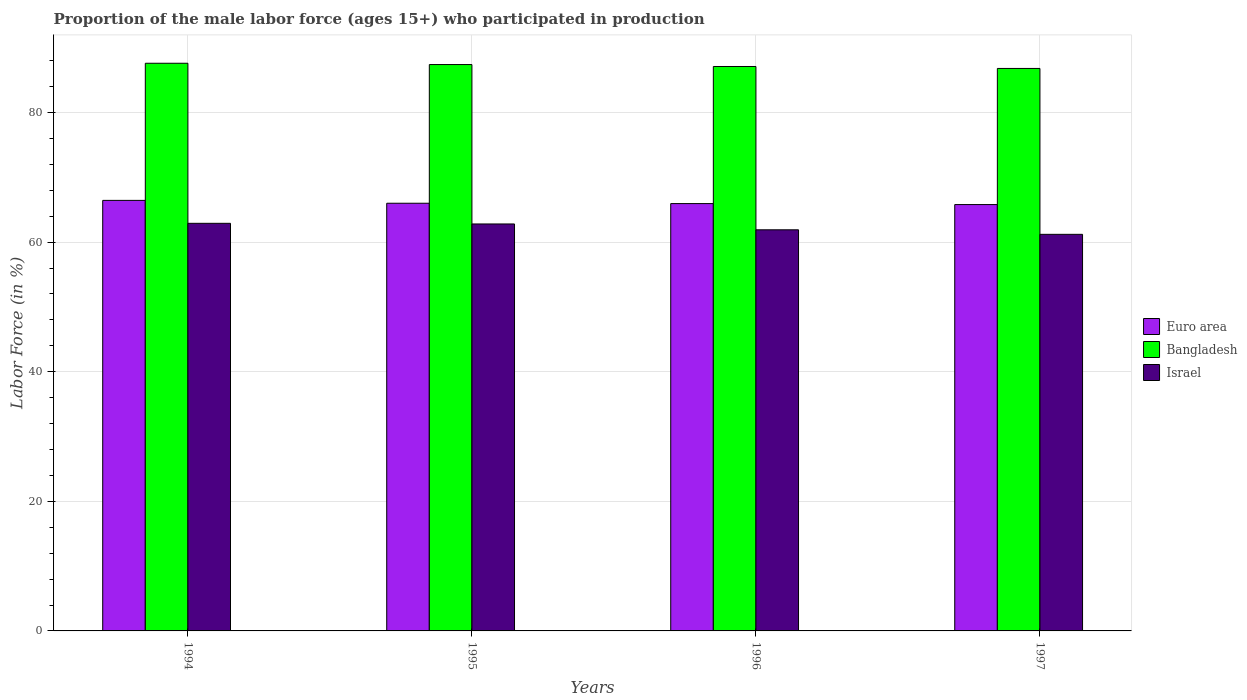How many different coloured bars are there?
Your answer should be compact. 3. Are the number of bars per tick equal to the number of legend labels?
Make the answer very short. Yes. How many bars are there on the 3rd tick from the left?
Your answer should be compact. 3. What is the label of the 3rd group of bars from the left?
Your answer should be very brief. 1996. What is the proportion of the male labor force who participated in production in Israel in 1997?
Your answer should be very brief. 61.2. Across all years, what is the maximum proportion of the male labor force who participated in production in Euro area?
Provide a short and direct response. 66.44. Across all years, what is the minimum proportion of the male labor force who participated in production in Euro area?
Provide a short and direct response. 65.79. In which year was the proportion of the male labor force who participated in production in Bangladesh maximum?
Provide a short and direct response. 1994. In which year was the proportion of the male labor force who participated in production in Euro area minimum?
Your answer should be compact. 1997. What is the total proportion of the male labor force who participated in production in Bangladesh in the graph?
Your response must be concise. 348.9. What is the difference between the proportion of the male labor force who participated in production in Israel in 1996 and that in 1997?
Provide a succinct answer. 0.7. What is the difference between the proportion of the male labor force who participated in production in Israel in 1996 and the proportion of the male labor force who participated in production in Bangladesh in 1994?
Your response must be concise. -25.7. What is the average proportion of the male labor force who participated in production in Euro area per year?
Your answer should be compact. 66.04. In the year 1996, what is the difference between the proportion of the male labor force who participated in production in Israel and proportion of the male labor force who participated in production in Bangladesh?
Ensure brevity in your answer.  -25.2. In how many years, is the proportion of the male labor force who participated in production in Bangladesh greater than 8 %?
Provide a succinct answer. 4. What is the ratio of the proportion of the male labor force who participated in production in Euro area in 1996 to that in 1997?
Offer a terse response. 1. Is the difference between the proportion of the male labor force who participated in production in Israel in 1994 and 1996 greater than the difference between the proportion of the male labor force who participated in production in Bangladesh in 1994 and 1996?
Your response must be concise. Yes. What is the difference between the highest and the second highest proportion of the male labor force who participated in production in Israel?
Your response must be concise. 0.1. What is the difference between the highest and the lowest proportion of the male labor force who participated in production in Bangladesh?
Offer a terse response. 0.8. In how many years, is the proportion of the male labor force who participated in production in Bangladesh greater than the average proportion of the male labor force who participated in production in Bangladesh taken over all years?
Offer a terse response. 2. Is the sum of the proportion of the male labor force who participated in production in Israel in 1994 and 1996 greater than the maximum proportion of the male labor force who participated in production in Bangladesh across all years?
Offer a very short reply. Yes. What does the 2nd bar from the right in 1995 represents?
Keep it short and to the point. Bangladesh. Is it the case that in every year, the sum of the proportion of the male labor force who participated in production in Israel and proportion of the male labor force who participated in production in Bangladesh is greater than the proportion of the male labor force who participated in production in Euro area?
Provide a succinct answer. Yes. How many bars are there?
Make the answer very short. 12. Are all the bars in the graph horizontal?
Offer a terse response. No. What is the difference between two consecutive major ticks on the Y-axis?
Offer a terse response. 20. Are the values on the major ticks of Y-axis written in scientific E-notation?
Offer a very short reply. No. Where does the legend appear in the graph?
Your answer should be very brief. Center right. How many legend labels are there?
Keep it short and to the point. 3. How are the legend labels stacked?
Provide a short and direct response. Vertical. What is the title of the graph?
Ensure brevity in your answer.  Proportion of the male labor force (ages 15+) who participated in production. What is the label or title of the X-axis?
Ensure brevity in your answer.  Years. What is the label or title of the Y-axis?
Make the answer very short. Labor Force (in %). What is the Labor Force (in %) in Euro area in 1994?
Keep it short and to the point. 66.44. What is the Labor Force (in %) of Bangladesh in 1994?
Make the answer very short. 87.6. What is the Labor Force (in %) in Israel in 1994?
Give a very brief answer. 62.9. What is the Labor Force (in %) of Euro area in 1995?
Make the answer very short. 66. What is the Labor Force (in %) in Bangladesh in 1995?
Keep it short and to the point. 87.4. What is the Labor Force (in %) in Israel in 1995?
Your answer should be compact. 62.8. What is the Labor Force (in %) in Euro area in 1996?
Ensure brevity in your answer.  65.95. What is the Labor Force (in %) of Bangladesh in 1996?
Your answer should be very brief. 87.1. What is the Labor Force (in %) of Israel in 1996?
Provide a succinct answer. 61.9. What is the Labor Force (in %) of Euro area in 1997?
Your answer should be compact. 65.79. What is the Labor Force (in %) in Bangladesh in 1997?
Keep it short and to the point. 86.8. What is the Labor Force (in %) of Israel in 1997?
Make the answer very short. 61.2. Across all years, what is the maximum Labor Force (in %) of Euro area?
Offer a terse response. 66.44. Across all years, what is the maximum Labor Force (in %) of Bangladesh?
Your answer should be very brief. 87.6. Across all years, what is the maximum Labor Force (in %) of Israel?
Your answer should be very brief. 62.9. Across all years, what is the minimum Labor Force (in %) in Euro area?
Provide a short and direct response. 65.79. Across all years, what is the minimum Labor Force (in %) of Bangladesh?
Ensure brevity in your answer.  86.8. Across all years, what is the minimum Labor Force (in %) in Israel?
Ensure brevity in your answer.  61.2. What is the total Labor Force (in %) in Euro area in the graph?
Provide a short and direct response. 264.18. What is the total Labor Force (in %) of Bangladesh in the graph?
Provide a succinct answer. 348.9. What is the total Labor Force (in %) in Israel in the graph?
Your response must be concise. 248.8. What is the difference between the Labor Force (in %) in Euro area in 1994 and that in 1995?
Offer a very short reply. 0.44. What is the difference between the Labor Force (in %) in Israel in 1994 and that in 1995?
Your answer should be compact. 0.1. What is the difference between the Labor Force (in %) in Euro area in 1994 and that in 1996?
Provide a short and direct response. 0.49. What is the difference between the Labor Force (in %) of Israel in 1994 and that in 1996?
Ensure brevity in your answer.  1. What is the difference between the Labor Force (in %) in Euro area in 1994 and that in 1997?
Give a very brief answer. 0.65. What is the difference between the Labor Force (in %) of Bangladesh in 1994 and that in 1997?
Your answer should be compact. 0.8. What is the difference between the Labor Force (in %) of Euro area in 1995 and that in 1996?
Provide a succinct answer. 0.05. What is the difference between the Labor Force (in %) in Euro area in 1995 and that in 1997?
Provide a succinct answer. 0.2. What is the difference between the Labor Force (in %) of Bangladesh in 1995 and that in 1997?
Your response must be concise. 0.6. What is the difference between the Labor Force (in %) in Israel in 1995 and that in 1997?
Offer a very short reply. 1.6. What is the difference between the Labor Force (in %) of Euro area in 1996 and that in 1997?
Your answer should be very brief. 0.15. What is the difference between the Labor Force (in %) in Euro area in 1994 and the Labor Force (in %) in Bangladesh in 1995?
Your response must be concise. -20.96. What is the difference between the Labor Force (in %) in Euro area in 1994 and the Labor Force (in %) in Israel in 1995?
Your answer should be compact. 3.64. What is the difference between the Labor Force (in %) in Bangladesh in 1994 and the Labor Force (in %) in Israel in 1995?
Your answer should be compact. 24.8. What is the difference between the Labor Force (in %) of Euro area in 1994 and the Labor Force (in %) of Bangladesh in 1996?
Make the answer very short. -20.66. What is the difference between the Labor Force (in %) in Euro area in 1994 and the Labor Force (in %) in Israel in 1996?
Make the answer very short. 4.54. What is the difference between the Labor Force (in %) in Bangladesh in 1994 and the Labor Force (in %) in Israel in 1996?
Your response must be concise. 25.7. What is the difference between the Labor Force (in %) in Euro area in 1994 and the Labor Force (in %) in Bangladesh in 1997?
Provide a succinct answer. -20.36. What is the difference between the Labor Force (in %) in Euro area in 1994 and the Labor Force (in %) in Israel in 1997?
Offer a very short reply. 5.24. What is the difference between the Labor Force (in %) in Bangladesh in 1994 and the Labor Force (in %) in Israel in 1997?
Make the answer very short. 26.4. What is the difference between the Labor Force (in %) in Euro area in 1995 and the Labor Force (in %) in Bangladesh in 1996?
Make the answer very short. -21.1. What is the difference between the Labor Force (in %) of Euro area in 1995 and the Labor Force (in %) of Israel in 1996?
Your answer should be very brief. 4.1. What is the difference between the Labor Force (in %) of Euro area in 1995 and the Labor Force (in %) of Bangladesh in 1997?
Offer a very short reply. -20.8. What is the difference between the Labor Force (in %) of Euro area in 1995 and the Labor Force (in %) of Israel in 1997?
Your answer should be compact. 4.8. What is the difference between the Labor Force (in %) of Bangladesh in 1995 and the Labor Force (in %) of Israel in 1997?
Your response must be concise. 26.2. What is the difference between the Labor Force (in %) in Euro area in 1996 and the Labor Force (in %) in Bangladesh in 1997?
Offer a terse response. -20.85. What is the difference between the Labor Force (in %) of Euro area in 1996 and the Labor Force (in %) of Israel in 1997?
Offer a very short reply. 4.75. What is the difference between the Labor Force (in %) in Bangladesh in 1996 and the Labor Force (in %) in Israel in 1997?
Provide a short and direct response. 25.9. What is the average Labor Force (in %) of Euro area per year?
Your response must be concise. 66.04. What is the average Labor Force (in %) of Bangladesh per year?
Give a very brief answer. 87.22. What is the average Labor Force (in %) of Israel per year?
Provide a succinct answer. 62.2. In the year 1994, what is the difference between the Labor Force (in %) in Euro area and Labor Force (in %) in Bangladesh?
Offer a very short reply. -21.16. In the year 1994, what is the difference between the Labor Force (in %) of Euro area and Labor Force (in %) of Israel?
Offer a terse response. 3.54. In the year 1994, what is the difference between the Labor Force (in %) of Bangladesh and Labor Force (in %) of Israel?
Provide a short and direct response. 24.7. In the year 1995, what is the difference between the Labor Force (in %) of Euro area and Labor Force (in %) of Bangladesh?
Your response must be concise. -21.4. In the year 1995, what is the difference between the Labor Force (in %) in Euro area and Labor Force (in %) in Israel?
Provide a succinct answer. 3.2. In the year 1995, what is the difference between the Labor Force (in %) of Bangladesh and Labor Force (in %) of Israel?
Offer a very short reply. 24.6. In the year 1996, what is the difference between the Labor Force (in %) of Euro area and Labor Force (in %) of Bangladesh?
Provide a succinct answer. -21.15. In the year 1996, what is the difference between the Labor Force (in %) in Euro area and Labor Force (in %) in Israel?
Your response must be concise. 4.05. In the year 1996, what is the difference between the Labor Force (in %) of Bangladesh and Labor Force (in %) of Israel?
Offer a very short reply. 25.2. In the year 1997, what is the difference between the Labor Force (in %) of Euro area and Labor Force (in %) of Bangladesh?
Your answer should be very brief. -21.01. In the year 1997, what is the difference between the Labor Force (in %) in Euro area and Labor Force (in %) in Israel?
Provide a succinct answer. 4.59. In the year 1997, what is the difference between the Labor Force (in %) of Bangladesh and Labor Force (in %) of Israel?
Your answer should be compact. 25.6. What is the ratio of the Labor Force (in %) of Israel in 1994 to that in 1995?
Your answer should be very brief. 1. What is the ratio of the Labor Force (in %) in Euro area in 1994 to that in 1996?
Make the answer very short. 1.01. What is the ratio of the Labor Force (in %) in Israel in 1994 to that in 1996?
Your answer should be compact. 1.02. What is the ratio of the Labor Force (in %) in Euro area in 1994 to that in 1997?
Make the answer very short. 1.01. What is the ratio of the Labor Force (in %) in Bangladesh in 1994 to that in 1997?
Provide a short and direct response. 1.01. What is the ratio of the Labor Force (in %) in Israel in 1994 to that in 1997?
Your answer should be very brief. 1.03. What is the ratio of the Labor Force (in %) in Israel in 1995 to that in 1996?
Ensure brevity in your answer.  1.01. What is the ratio of the Labor Force (in %) of Israel in 1995 to that in 1997?
Keep it short and to the point. 1.03. What is the ratio of the Labor Force (in %) in Israel in 1996 to that in 1997?
Give a very brief answer. 1.01. What is the difference between the highest and the second highest Labor Force (in %) of Euro area?
Ensure brevity in your answer.  0.44. What is the difference between the highest and the second highest Labor Force (in %) of Bangladesh?
Your response must be concise. 0.2. What is the difference between the highest and the second highest Labor Force (in %) of Israel?
Your answer should be compact. 0.1. What is the difference between the highest and the lowest Labor Force (in %) of Euro area?
Your response must be concise. 0.65. What is the difference between the highest and the lowest Labor Force (in %) in Bangladesh?
Make the answer very short. 0.8. What is the difference between the highest and the lowest Labor Force (in %) of Israel?
Give a very brief answer. 1.7. 